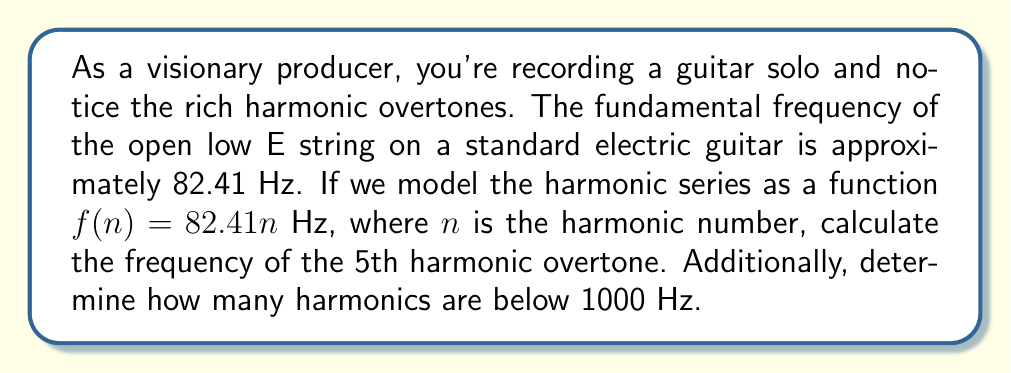Help me with this question. To solve this problem, we'll use the given function for the harmonic series and apply it to find the requested values.

1. Finding the frequency of the 5th harmonic overtone:
   The harmonic series function is given as $f(n) = 82.41n$ Hz, where $n$ is the harmonic number.
   For the 5th harmonic overtone, $n = 6$ (as the fundamental is $n = 1$).
   
   $$f(6) = 82.41 \cdot 6 = 494.46\text{ Hz}$$

2. Determining how many harmonics are below 1000 Hz:
   We need to find the largest value of $n$ for which $f(n) < 1000$ Hz.
   
   $$82.41n < 1000$$
   $$n < \frac{1000}{82.41}$$
   $$n < 12.13$$
   
   Since $n$ must be a whole number, the largest value that satisfies this inequality is 12.

This means there are 12 harmonics (including the fundamental) below 1000 Hz.
Answer: The frequency of the 5th harmonic overtone is 494.46 Hz, and there are 12 harmonics below 1000 Hz. 